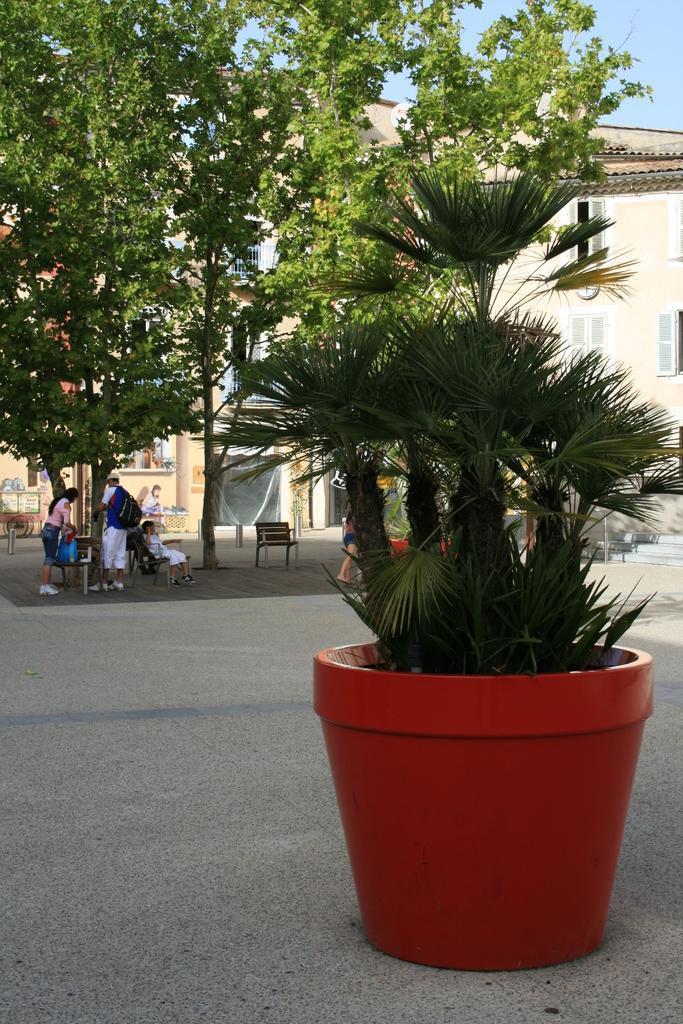In one or two sentences, can you explain what this image depicts? In the image we can see a plant pot, this is a footpath, there are trees, buildings and windows of the building and a sky. This is a bench, on the bench there is a person sitting and two of them are standing. These people are wearing clothes and shoes. 